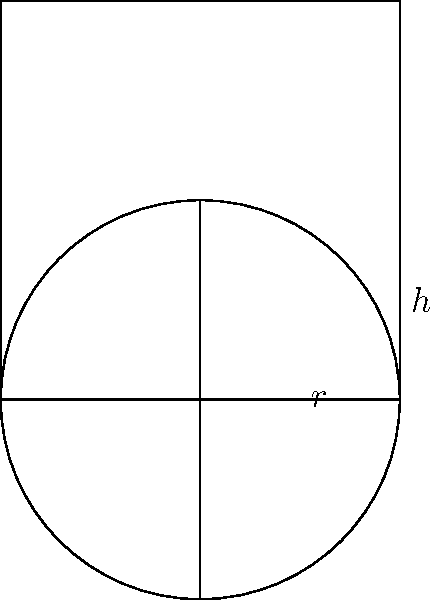The local water tower in South Roxana is cylindrical in shape. If the radius of the base is 15 feet and the height of the cylinder is 40 feet, what is the total volume of water the tower can hold? (Use $\pi \approx 3.14$ for your calculations) To find the volume of a cylindrical water tower, we need to use the formula for the volume of a cylinder:

$$V = \pi r^2 h$$

Where:
$V$ = volume
$r$ = radius of the base
$h$ = height of the cylinder

Given:
$r = 15$ feet
$h = 40$ feet
$\pi \approx 3.14$

Let's substitute these values into the formula:

$$V = 3.14 \times 15^2 \times 40$$

Now, let's calculate step by step:

1. Calculate $15^2$:
   $15^2 = 225$

2. Multiply by $\pi$ (3.14):
   $3.14 \times 225 = 706.5$

3. Multiply by the height (40):
   $706.5 \times 40 = 28,260$

Therefore, the volume of the water tower is 28,260 cubic feet.
Answer: 28,260 cubic feet 